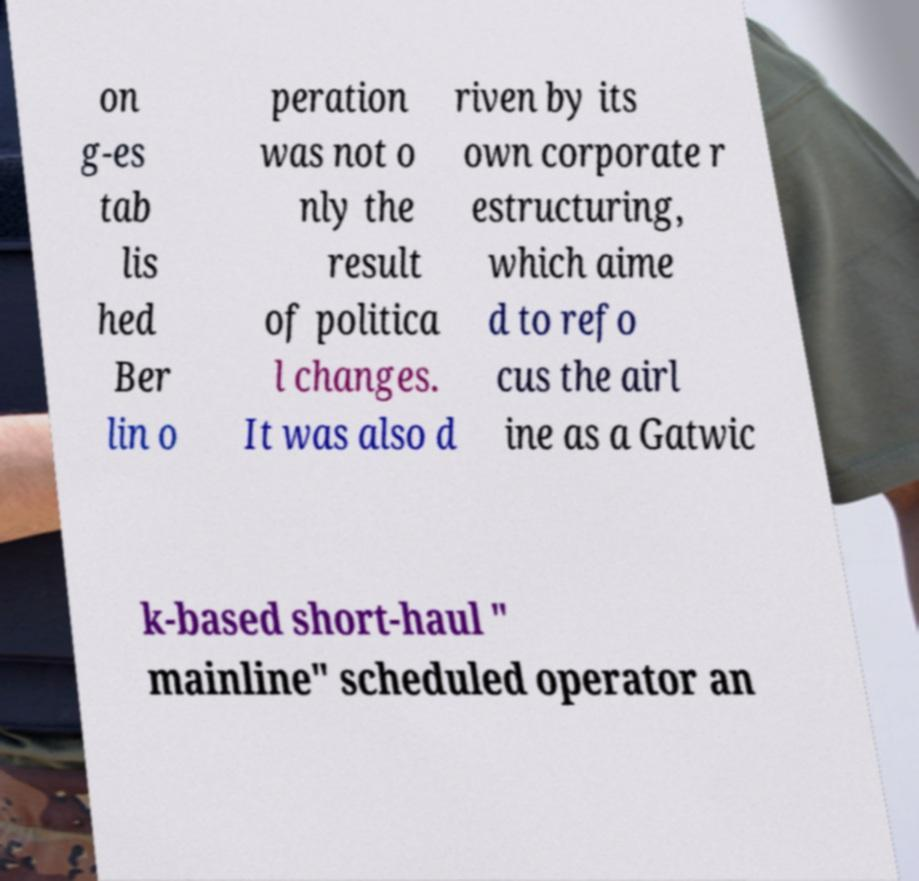I need the written content from this picture converted into text. Can you do that? on g-es tab lis hed Ber lin o peration was not o nly the result of politica l changes. It was also d riven by its own corporate r estructuring, which aime d to refo cus the airl ine as a Gatwic k-based short-haul " mainline" scheduled operator an 